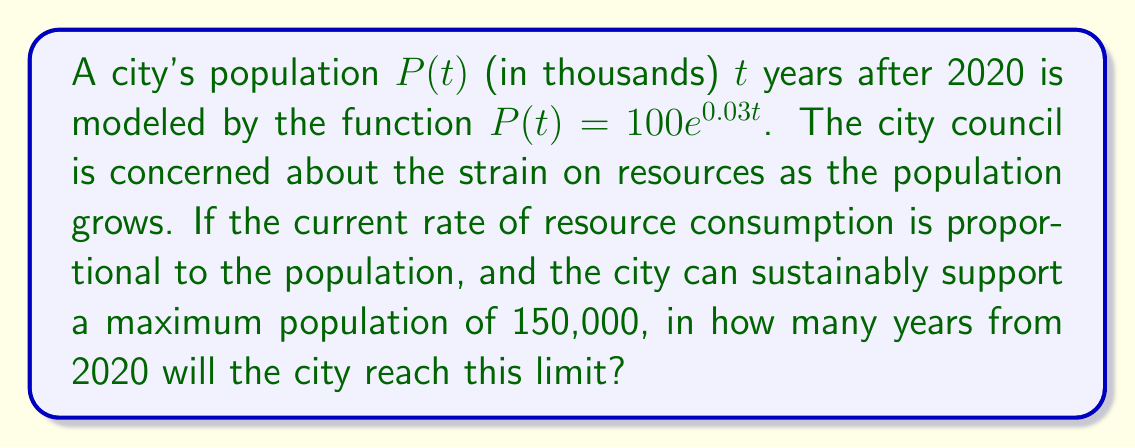Solve this math problem. Let's approach this step-by-step:

1) We need to find $t$ when $P(t) = 150$, as 150 thousand is 150,000.

2) Set up the equation:
   $$150 = 100e^{0.03t}$$

3) Divide both sides by 100:
   $$1.5 = e^{0.03t}$$

4) Take the natural logarithm of both sides:
   $$\ln(1.5) = \ln(e^{0.03t})$$

5) Simplify the right side using the property of logarithms:
   $$\ln(1.5) = 0.03t$$

6) Divide both sides by 0.03:
   $$\frac{\ln(1.5)}{0.03} = t$$

7) Calculate the value:
   $$t \approx 13.62$$

8) Since we can't have a fractional year in this context, we round up to the nearest whole year.
Answer: 14 years 